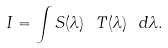<formula> <loc_0><loc_0><loc_500><loc_500>I = \int S ( \lambda ) \ T ( \lambda ) \ d \lambda .</formula> 